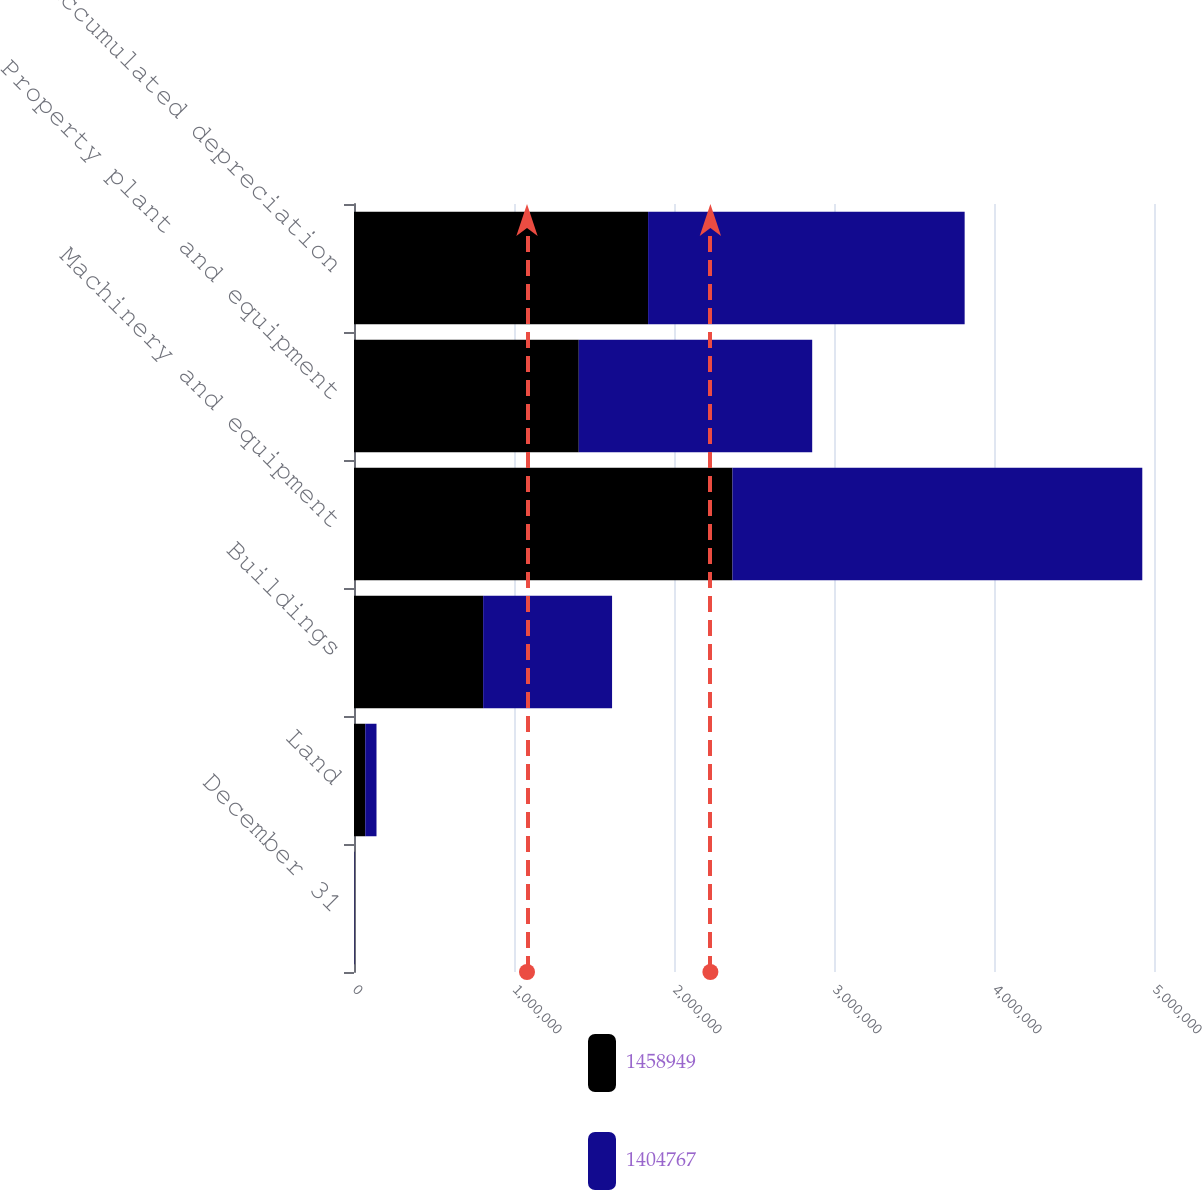Convert chart to OTSL. <chart><loc_0><loc_0><loc_500><loc_500><stacked_bar_chart><ecel><fcel>December 31<fcel>Land<fcel>Buildings<fcel>Machinery and equipment<fcel>Property plant and equipment<fcel>Accumulated depreciation<nl><fcel>1.45895e+06<fcel>2009<fcel>70388<fcel>807155<fcel>2.36532e+06<fcel>1.40477e+06<fcel>1.8381e+06<nl><fcel>1.40477e+06<fcel>2008<fcel>70226<fcel>805736<fcel>2.56146e+06<fcel>1.45895e+06<fcel>1.97847e+06<nl></chart> 